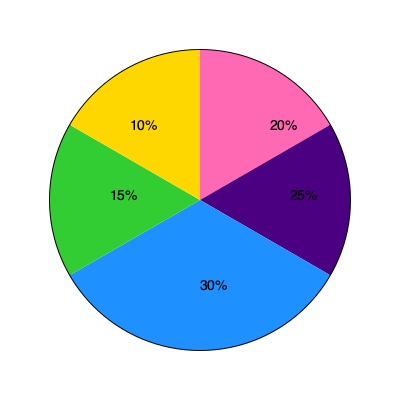The pie chart represents the funding allocation for women-led STEM research projects across different fields. If the total funding is $10 million, what is the difference in funding between the highest and lowest funded fields, and what percentage of the total funding does this difference represent? To solve this problem, we need to follow these steps:

1. Identify the highest and lowest funded fields:
   - Highest: 30% (Light Blue)
   - Lowest: 10% (Yellow)

2. Calculate the funding for each of these fields:
   - Highest: $10 million × 30% = $3 million
   - Lowest: $10 million × 10% = $1 million

3. Calculate the difference in funding:
   $3 million - $1 million = $2 million

4. Calculate what percentage this difference represents of the total funding:
   ($2 million / $10 million) × 100 = 20%

Therefore, the difference in funding between the highest and lowest funded fields is $2 million, which represents 20% of the total funding.
Answer: $2 million, 20% 